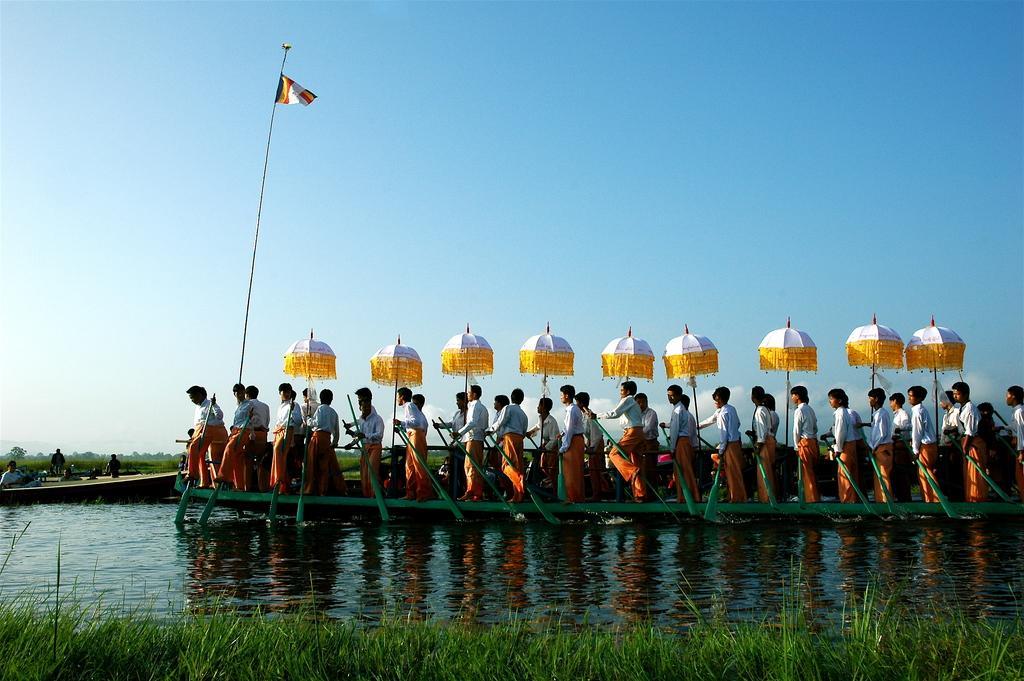Describe this image in one or two sentences. In the center of the image there are people riding a boat. At the bottom of the image there is grass and water. At the top of the image there is sky. There is a flag. 